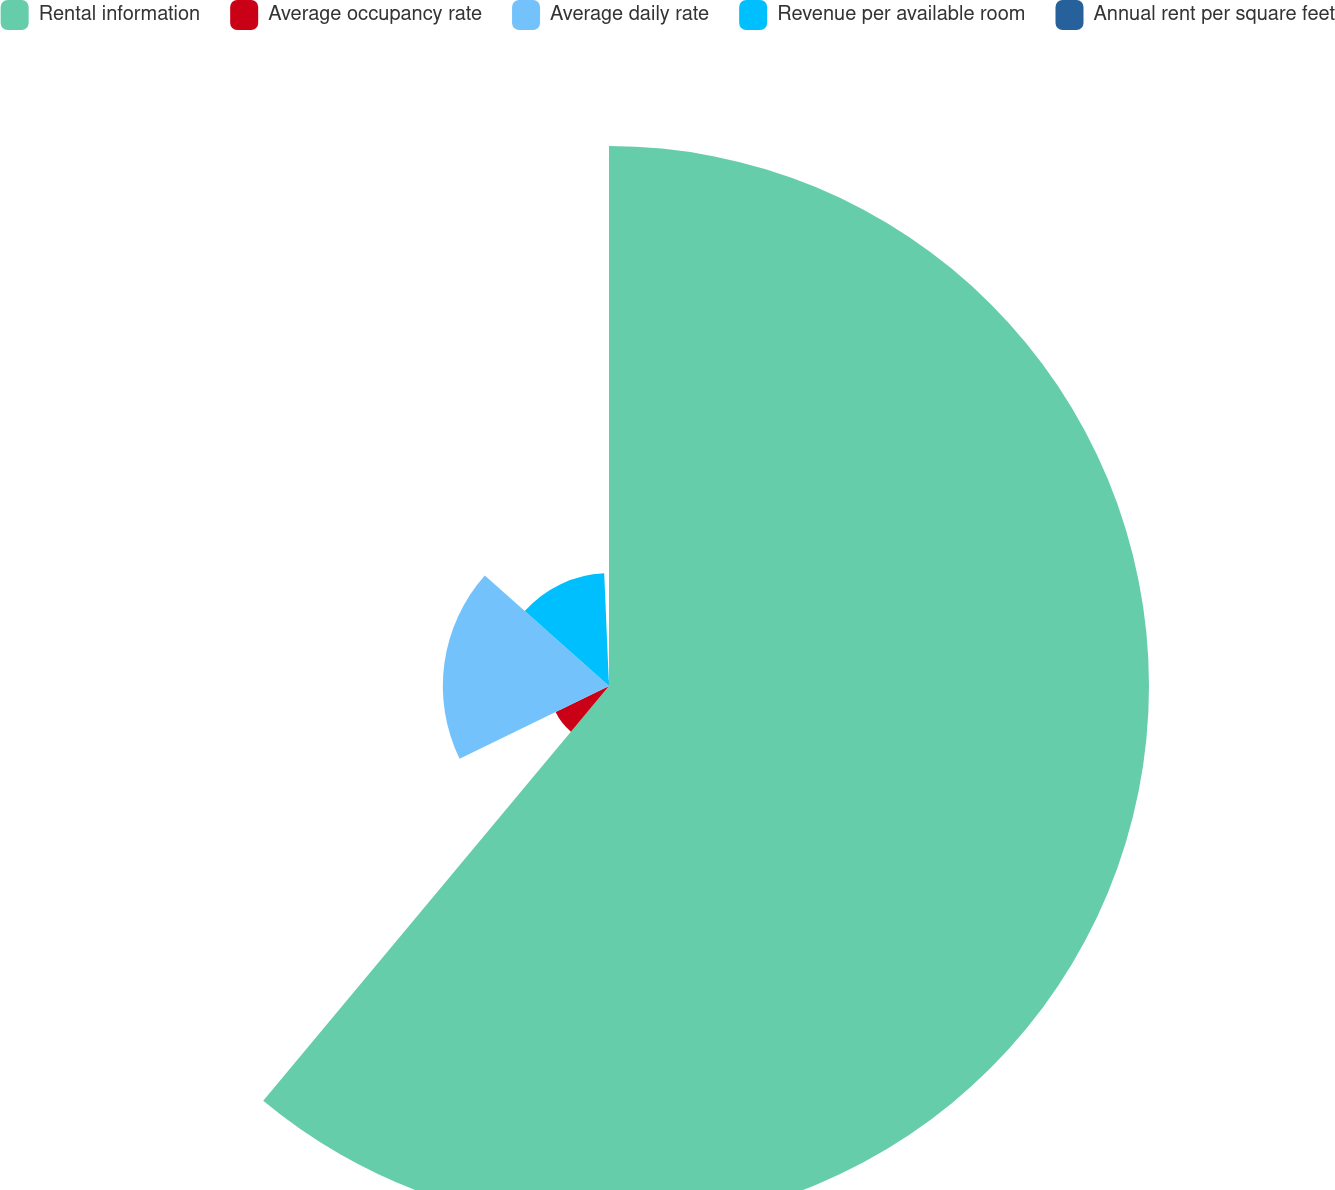Convert chart. <chart><loc_0><loc_0><loc_500><loc_500><pie_chart><fcel>Rental information<fcel>Average occupancy rate<fcel>Average daily rate<fcel>Revenue per available room<fcel>Annual rent per square feet<nl><fcel>61.06%<fcel>6.72%<fcel>18.79%<fcel>12.75%<fcel>0.68%<nl></chart> 